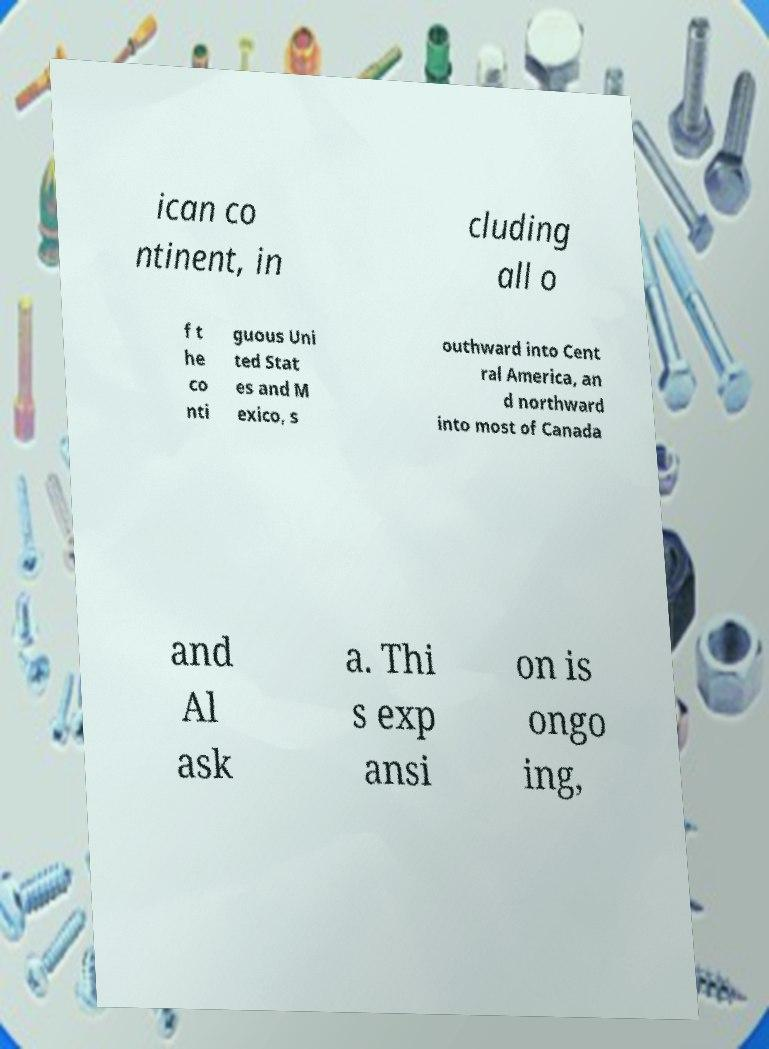Please read and relay the text visible in this image. What does it say? ican co ntinent, in cluding all o f t he co nti guous Uni ted Stat es and M exico, s outhward into Cent ral America, an d northward into most of Canada and Al ask a. Thi s exp ansi on is ongo ing, 